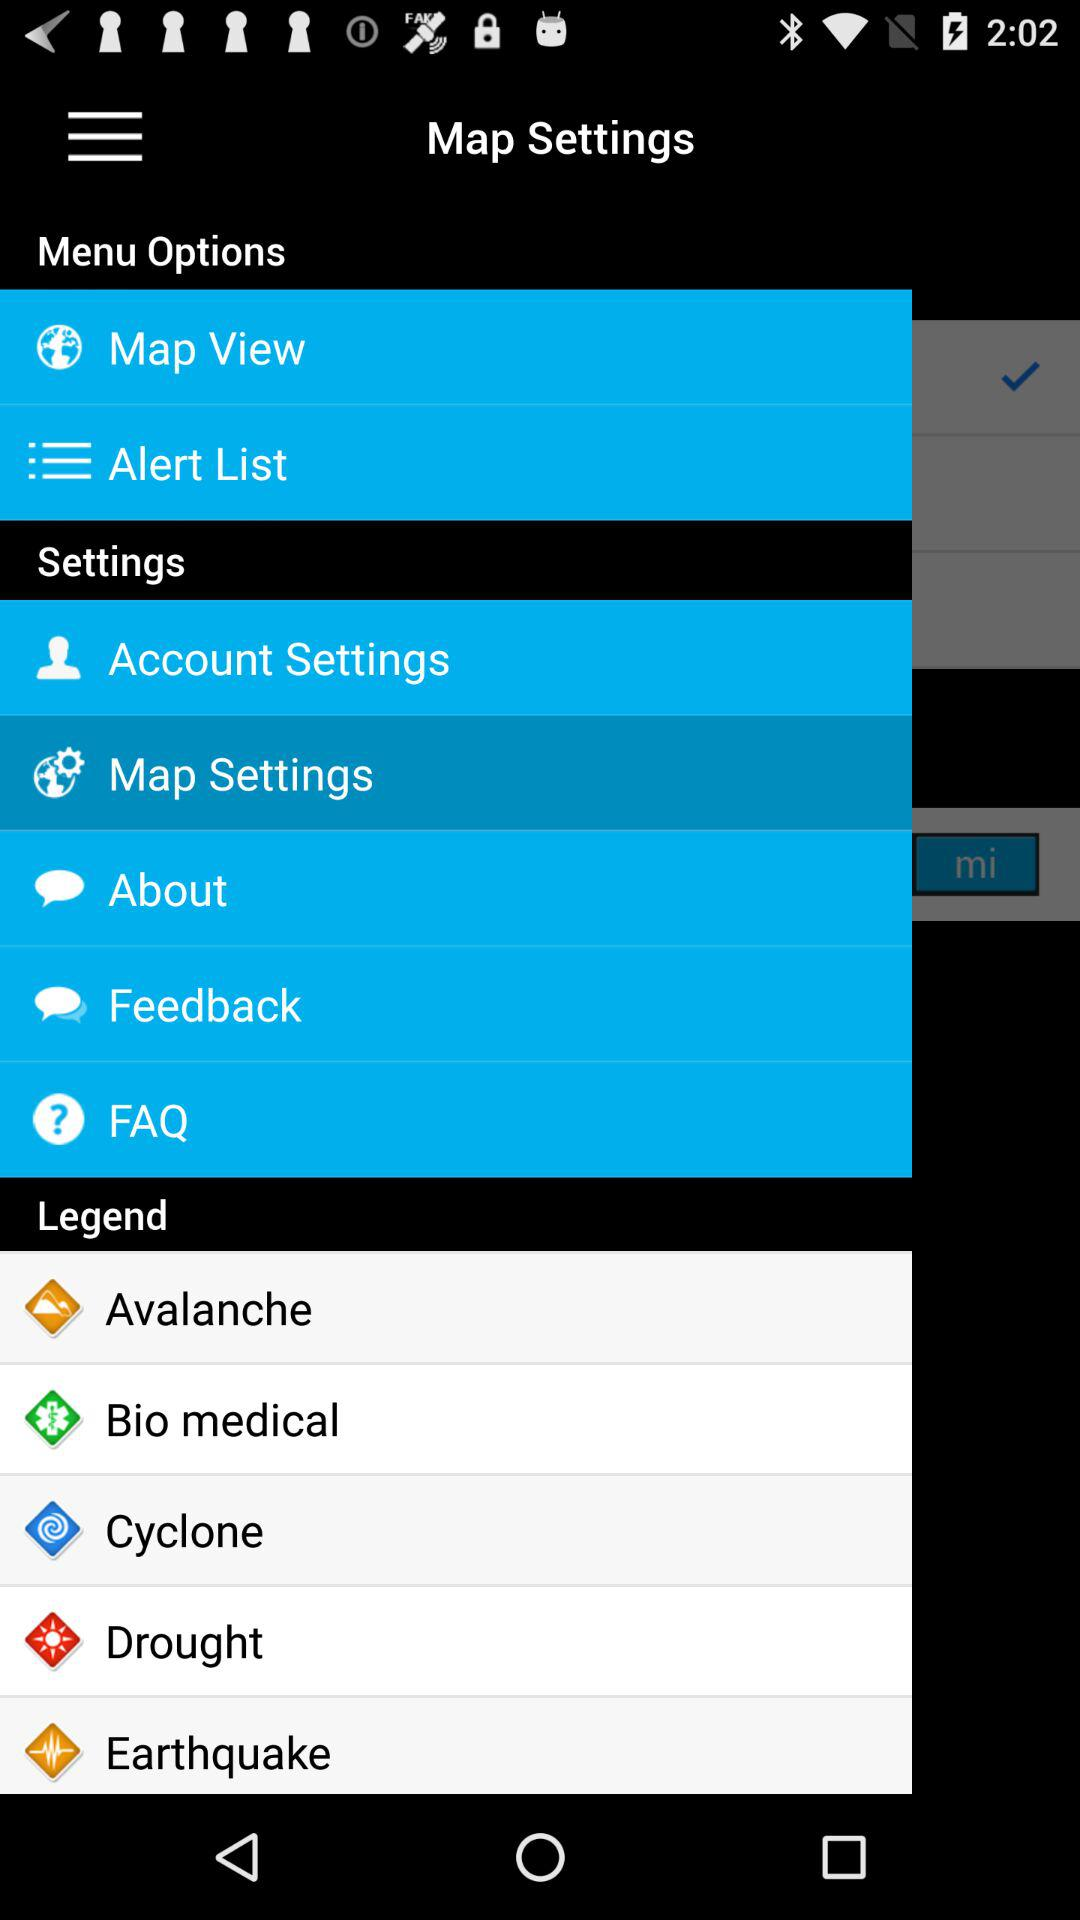Which item has been selected? The selected item is "Map Settings". 